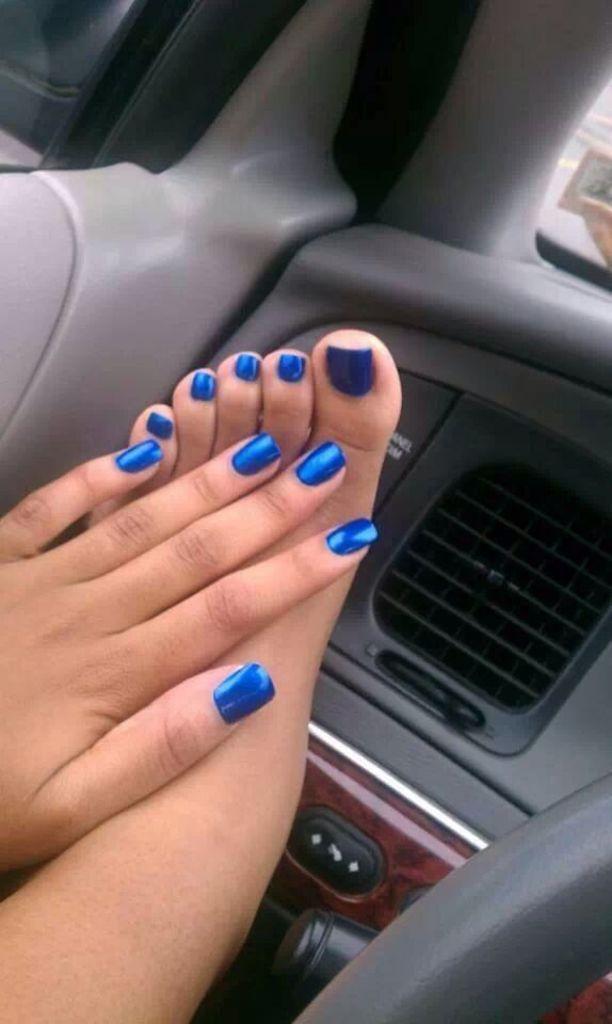Could you give a brief overview of what you see in this image? In this picture we can see a person hand and a leg, steering wheel and this is an inside view of a vehicle. 